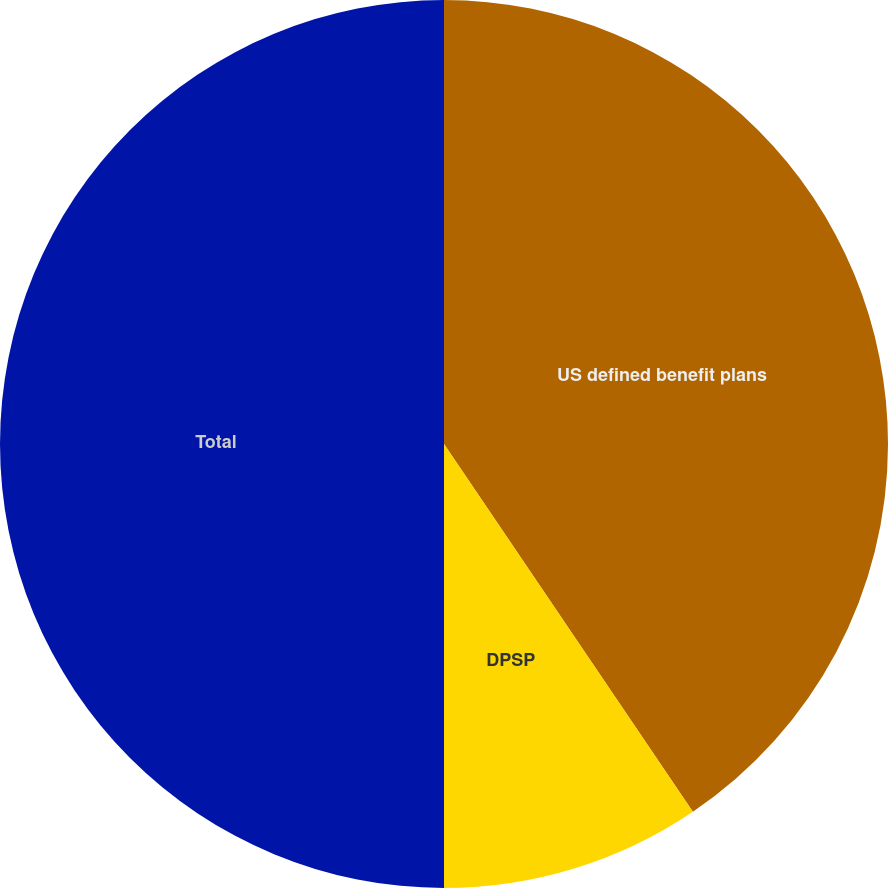Convert chart to OTSL. <chart><loc_0><loc_0><loc_500><loc_500><pie_chart><fcel>US defined benefit plans<fcel>DPSP<fcel>Total<nl><fcel>40.53%<fcel>9.47%<fcel>50.0%<nl></chart> 